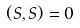<formula> <loc_0><loc_0><loc_500><loc_500>( S , S ) = 0</formula> 